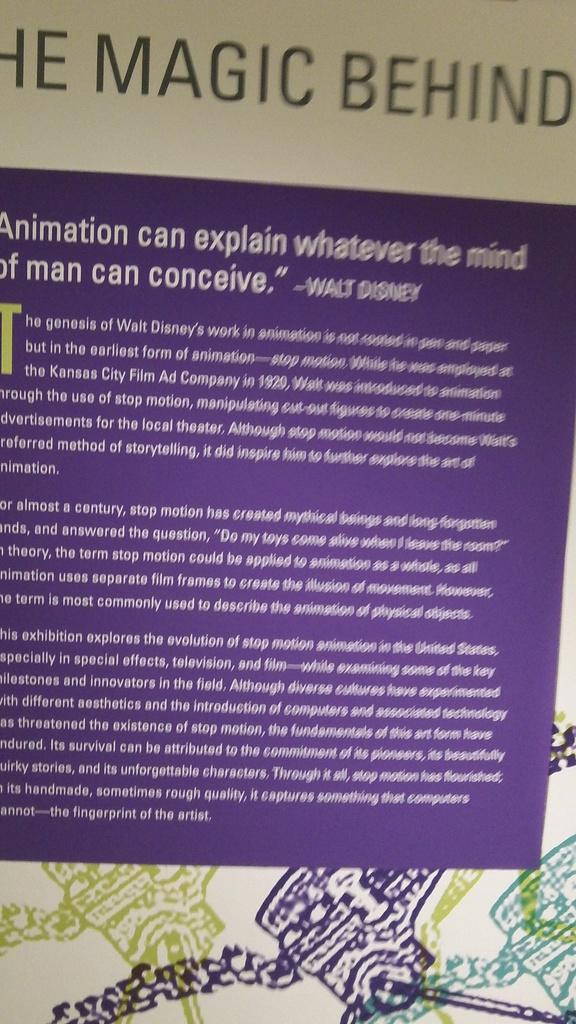<image>
Present a compact description of the photo's key features. An informative sign with a quote by Walt Disney  written near the top in white letters on a blue background. 